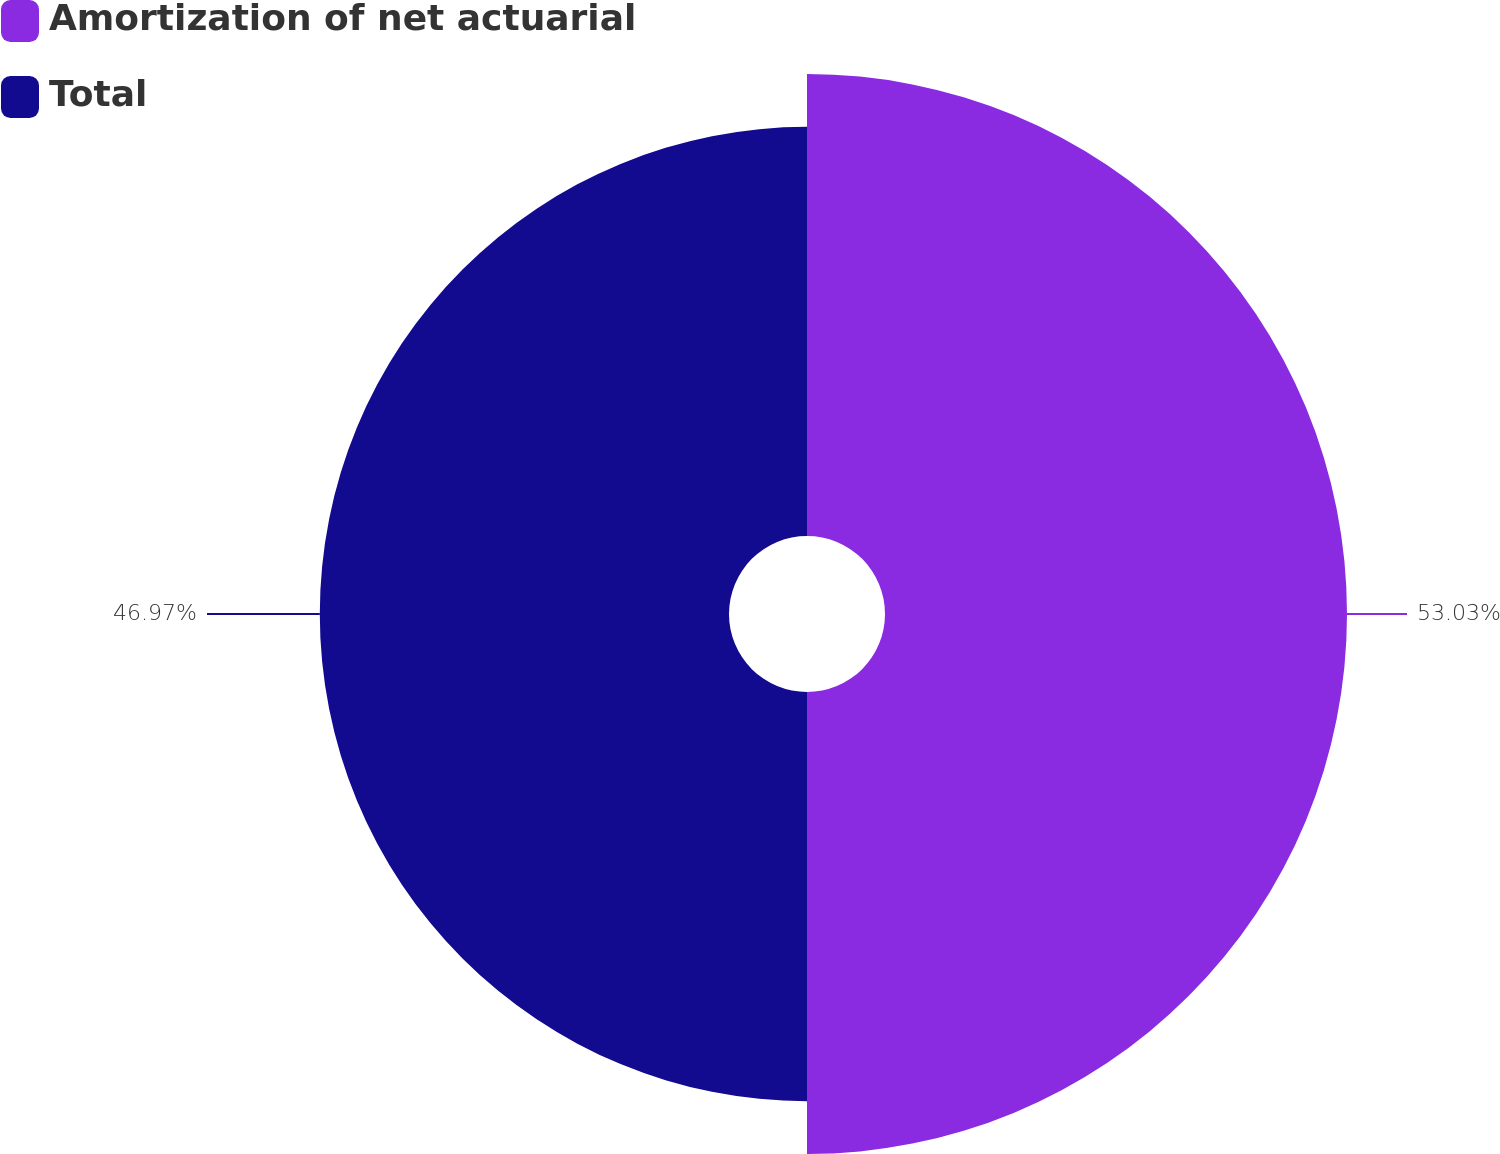<chart> <loc_0><loc_0><loc_500><loc_500><pie_chart><fcel>Amortization of net actuarial<fcel>Total<nl><fcel>53.03%<fcel>46.97%<nl></chart> 